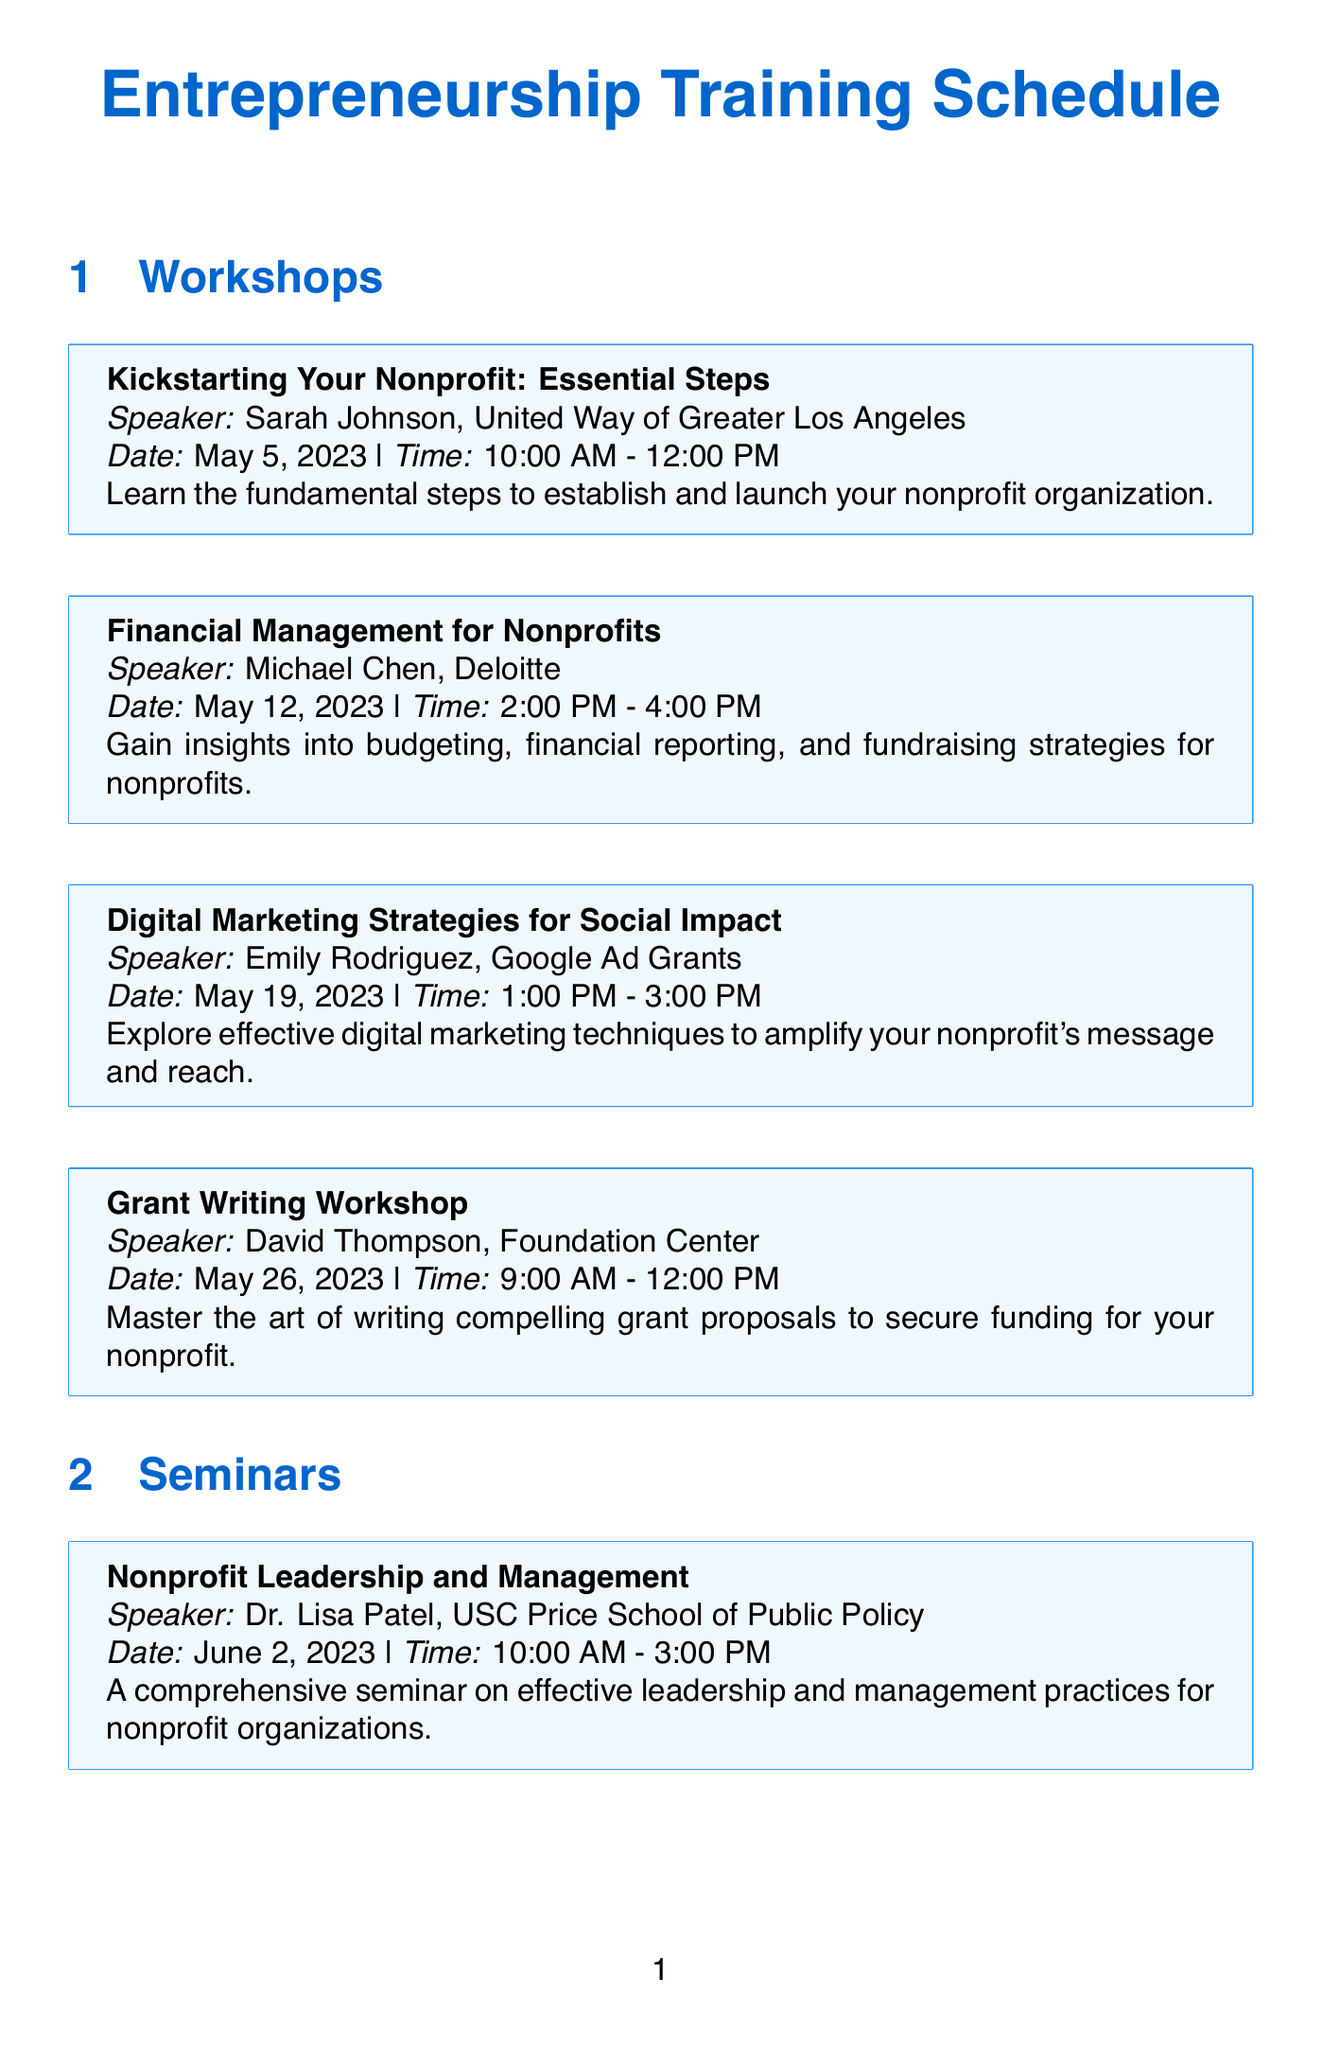What is the title of the workshop on May 5, 2023? The title of the workshop is listed directly under the date May 5, 2023, which is "Kickstarting Your Nonprofit: Essential Steps."
Answer: Kickstarting Your Nonprofit: Essential Steps Who is the speaker for the seminar on June 9, 2023? The speaker's name is mentioned in the seminar section for June 9, 2023, which is Alex Nguyen.
Answer: Alex Nguyen What organization is David Thompson associated with? The organization David Thompson is associated with is stated in the workshop details, which is the Foundation Center.
Answer: Foundation Center What time does the "Volunteer Management and Engagement" seminar begin? The starting time for this seminar is provided within its details, which is 9:00 AM.
Answer: 9:00 AM How many seminars are scheduled in June 2023? The total number of seminars can be counted from the list provided under June 2023, which is four.
Answer: Four Which topic is addressed in the workshop on May 19, 2023? The topic is found in the description of the workshop on that date, which is digital marketing strategies.
Answer: Digital Marketing Strategies for Social Impact What is the duration of the workshop titled "Financial Management for Nonprofits"? The duration is derived from the time listed for this workshop, which spans from 2:00 PM to 4:00 PM, totaling two hours.
Answer: Two hours Who is speaking at the "Strategic Partnerships and Collaborations" seminar? The speaker's name is included in the seminar details, which is Mark Williams.
Answer: Mark Williams 